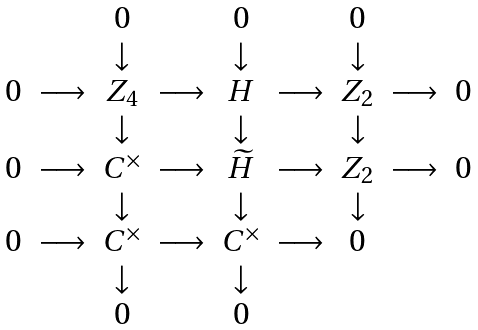<formula> <loc_0><loc_0><loc_500><loc_500>\begin{array} { c c c c c c c c c } & & 0 & & 0 & & 0 & & \\ & & \downarrow & & \downarrow & & \downarrow & & \\ 0 & \longrightarrow & { Z } _ { 4 } & \longrightarrow & { H } & \longrightarrow & { Z } _ { 2 } & \longrightarrow & 0 \\ & & \downarrow & & \downarrow & & \downarrow & & \\ 0 & \longrightarrow & { C } ^ { \times } & \longrightarrow & \widetilde { H } & \longrightarrow & { Z } _ { 2 } & \longrightarrow & 0 \\ & & \downarrow & & \downarrow & & \downarrow & & \\ 0 & \longrightarrow & { C } ^ { \times } & \longrightarrow & { C } ^ { \times } & \longrightarrow & 0 & & \\ & & \downarrow & & \downarrow & & & & \\ & & 0 & & 0 & & & & \end{array}</formula> 